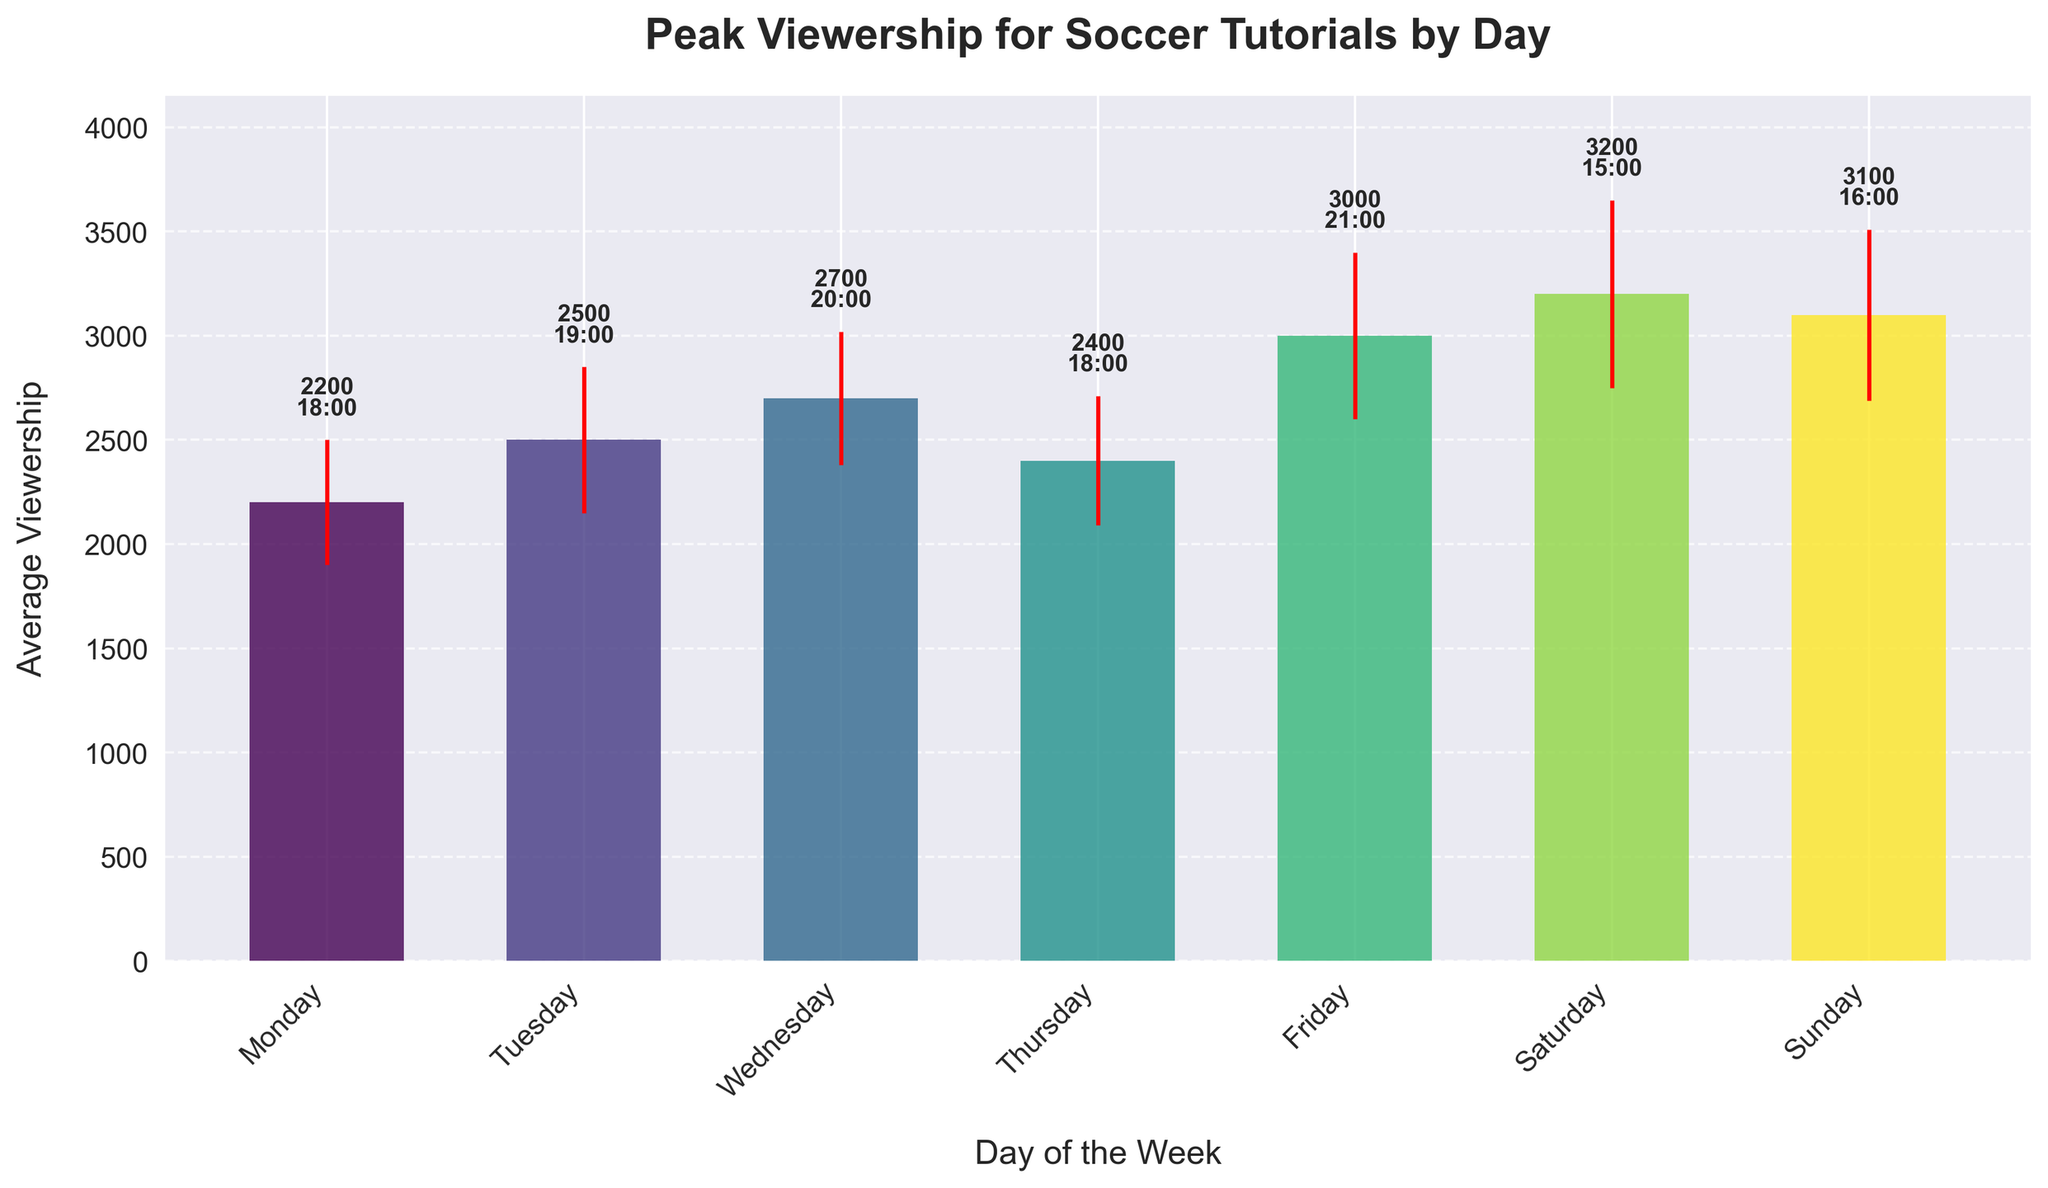What is the average viewership on Friday? The average viewership on Friday is indicated by the height of the bar for Friday.
Answer: 3000 Which day has the highest average viewership? By comparing the heights of all the bars, Saturday has the highest average viewership.
Answer: Saturday What is the peak viewership hour on Wednesday? The peak hour for each day is indicated by the text above the bars. For Wednesday, it is 20:00.
Answer: 20:00 Which day shows the largest fluctuation in viewership? The error bars indicate fluctuation, so the longest error bar implies the largest fluctuation. Saturday's error bar is the longest.
Answer: Saturday How much higher is the average viewership on Sunday compared to Monday? Subtract the average viewership of Monday (2200) from Sunday (3100).
Answer: 900 What is the total number of peak viewership hours after 18:00 across all days? Count the peak hours after 18:00: Tuesday (19:00), Wednesday (20:00), Friday (21:00), and Sunday (16:00). There are 4 such instances.
Answer: 4 Which day has the lowest average viewership and what is its value? By looking at the shortest bar, Monday has the lowest average viewership which is 2200.
Answer: Monday, 2200 What is the peak viewership hour on weekends and the average viewership during those hours? For weekends (Saturday and Sunday), the peak hours are 15:00 and 16:00 respectively. The average viewership is (3200 + 3100) / 2 = 3150.
Answer: 15:00, 16:00; 3150 Is the average viewership on Thursday greater than the average viewership on Tuesday? By comparing the heights of the bars, the average viewership on Thursday (2400) is less than that of Tuesday (2500).
Answer: No What is the range of average viewership values shown in the chart? Subtract the smallest average viewership value (2200) from the largest (3200).
Answer: 1000 